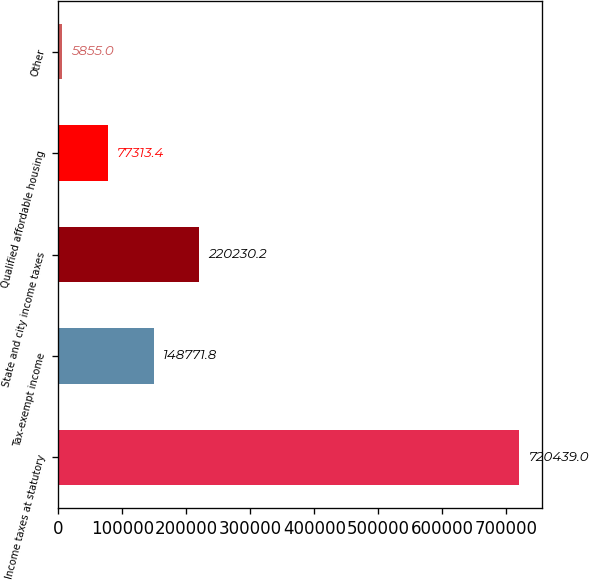<chart> <loc_0><loc_0><loc_500><loc_500><bar_chart><fcel>Income taxes at statutory<fcel>Tax-exempt income<fcel>State and city income taxes<fcel>Qualified affordable housing<fcel>Other<nl><fcel>720439<fcel>148772<fcel>220230<fcel>77313.4<fcel>5855<nl></chart> 